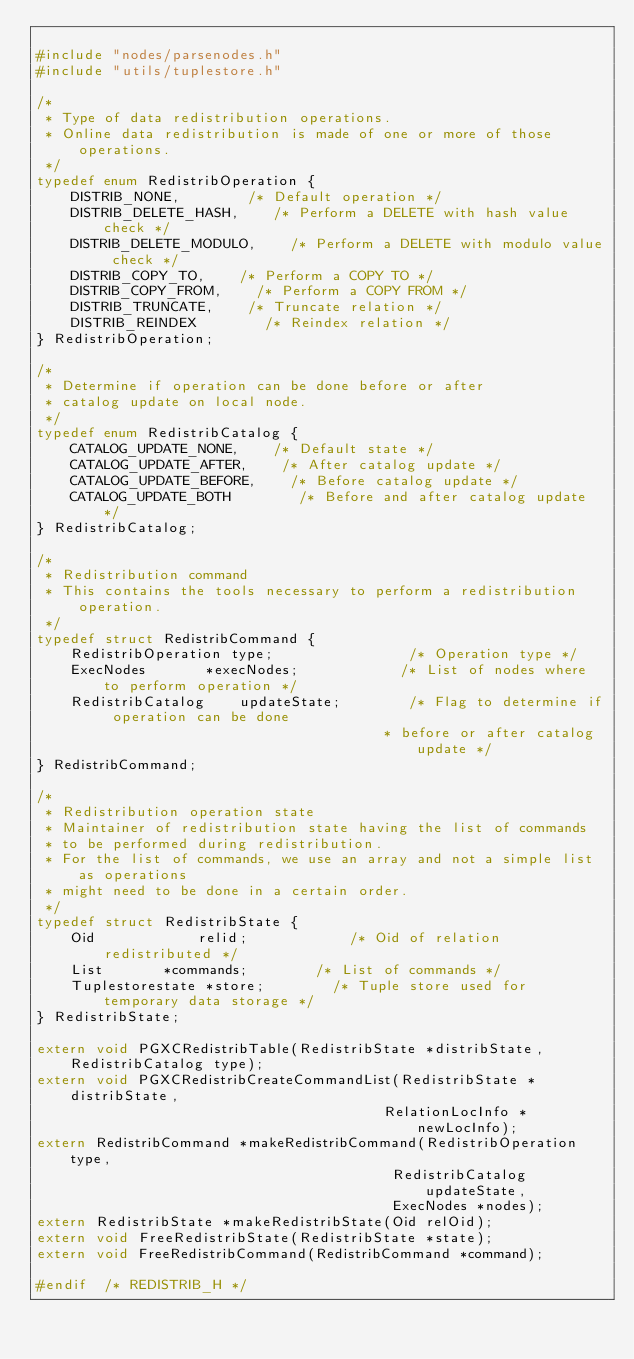Convert code to text. <code><loc_0><loc_0><loc_500><loc_500><_C_>
#include "nodes/parsenodes.h"
#include "utils/tuplestore.h"

/*
 * Type of data redistribution operations.
 * Online data redistribution is made of one or more of those operations.
 */
typedef enum RedistribOperation {
    DISTRIB_NONE,        /* Default operation */
    DISTRIB_DELETE_HASH,    /* Perform a DELETE with hash value check */
    DISTRIB_DELETE_MODULO,    /* Perform a DELETE with modulo value check */
    DISTRIB_COPY_TO,    /* Perform a COPY TO */
    DISTRIB_COPY_FROM,    /* Perform a COPY FROM */
    DISTRIB_TRUNCATE,    /* Truncate relation */
    DISTRIB_REINDEX        /* Reindex relation */
} RedistribOperation;

/*
 * Determine if operation can be done before or after
 * catalog update on local node.
 */
typedef enum RedistribCatalog {
    CATALOG_UPDATE_NONE,    /* Default state */
    CATALOG_UPDATE_AFTER,    /* After catalog update */
    CATALOG_UPDATE_BEFORE,    /* Before catalog update */
    CATALOG_UPDATE_BOTH        /* Before and after catalog update */
} RedistribCatalog;

/*
 * Redistribution command
 * This contains the tools necessary to perform a redistribution operation.
 */
typedef struct RedistribCommand {
    RedistribOperation type;                /* Operation type */
    ExecNodes       *execNodes;            /* List of nodes where to perform operation */
    RedistribCatalog    updateState;        /* Flag to determine if operation can be done
                                         * before or after catalog update */
} RedistribCommand;

/*
 * Redistribution operation state
 * Maintainer of redistribution state having the list of commands
 * to be performed during redistribution.
 * For the list of commands, we use an array and not a simple list as operations
 * might need to be done in a certain order.
 */
typedef struct RedistribState {
    Oid            relid;            /* Oid of relation redistributed */
    List       *commands;        /* List of commands */
    Tuplestorestate *store;        /* Tuple store used for temporary data storage */
} RedistribState;

extern void PGXCRedistribTable(RedistribState *distribState, RedistribCatalog type);
extern void PGXCRedistribCreateCommandList(RedistribState *distribState,
                                         RelationLocInfo *newLocInfo);
extern RedistribCommand *makeRedistribCommand(RedistribOperation type,
                                          RedistribCatalog updateState,
                                          ExecNodes *nodes);
extern RedistribState *makeRedistribState(Oid relOid);
extern void FreeRedistribState(RedistribState *state);
extern void FreeRedistribCommand(RedistribCommand *command);

#endif  /* REDISTRIB_H */
</code> 